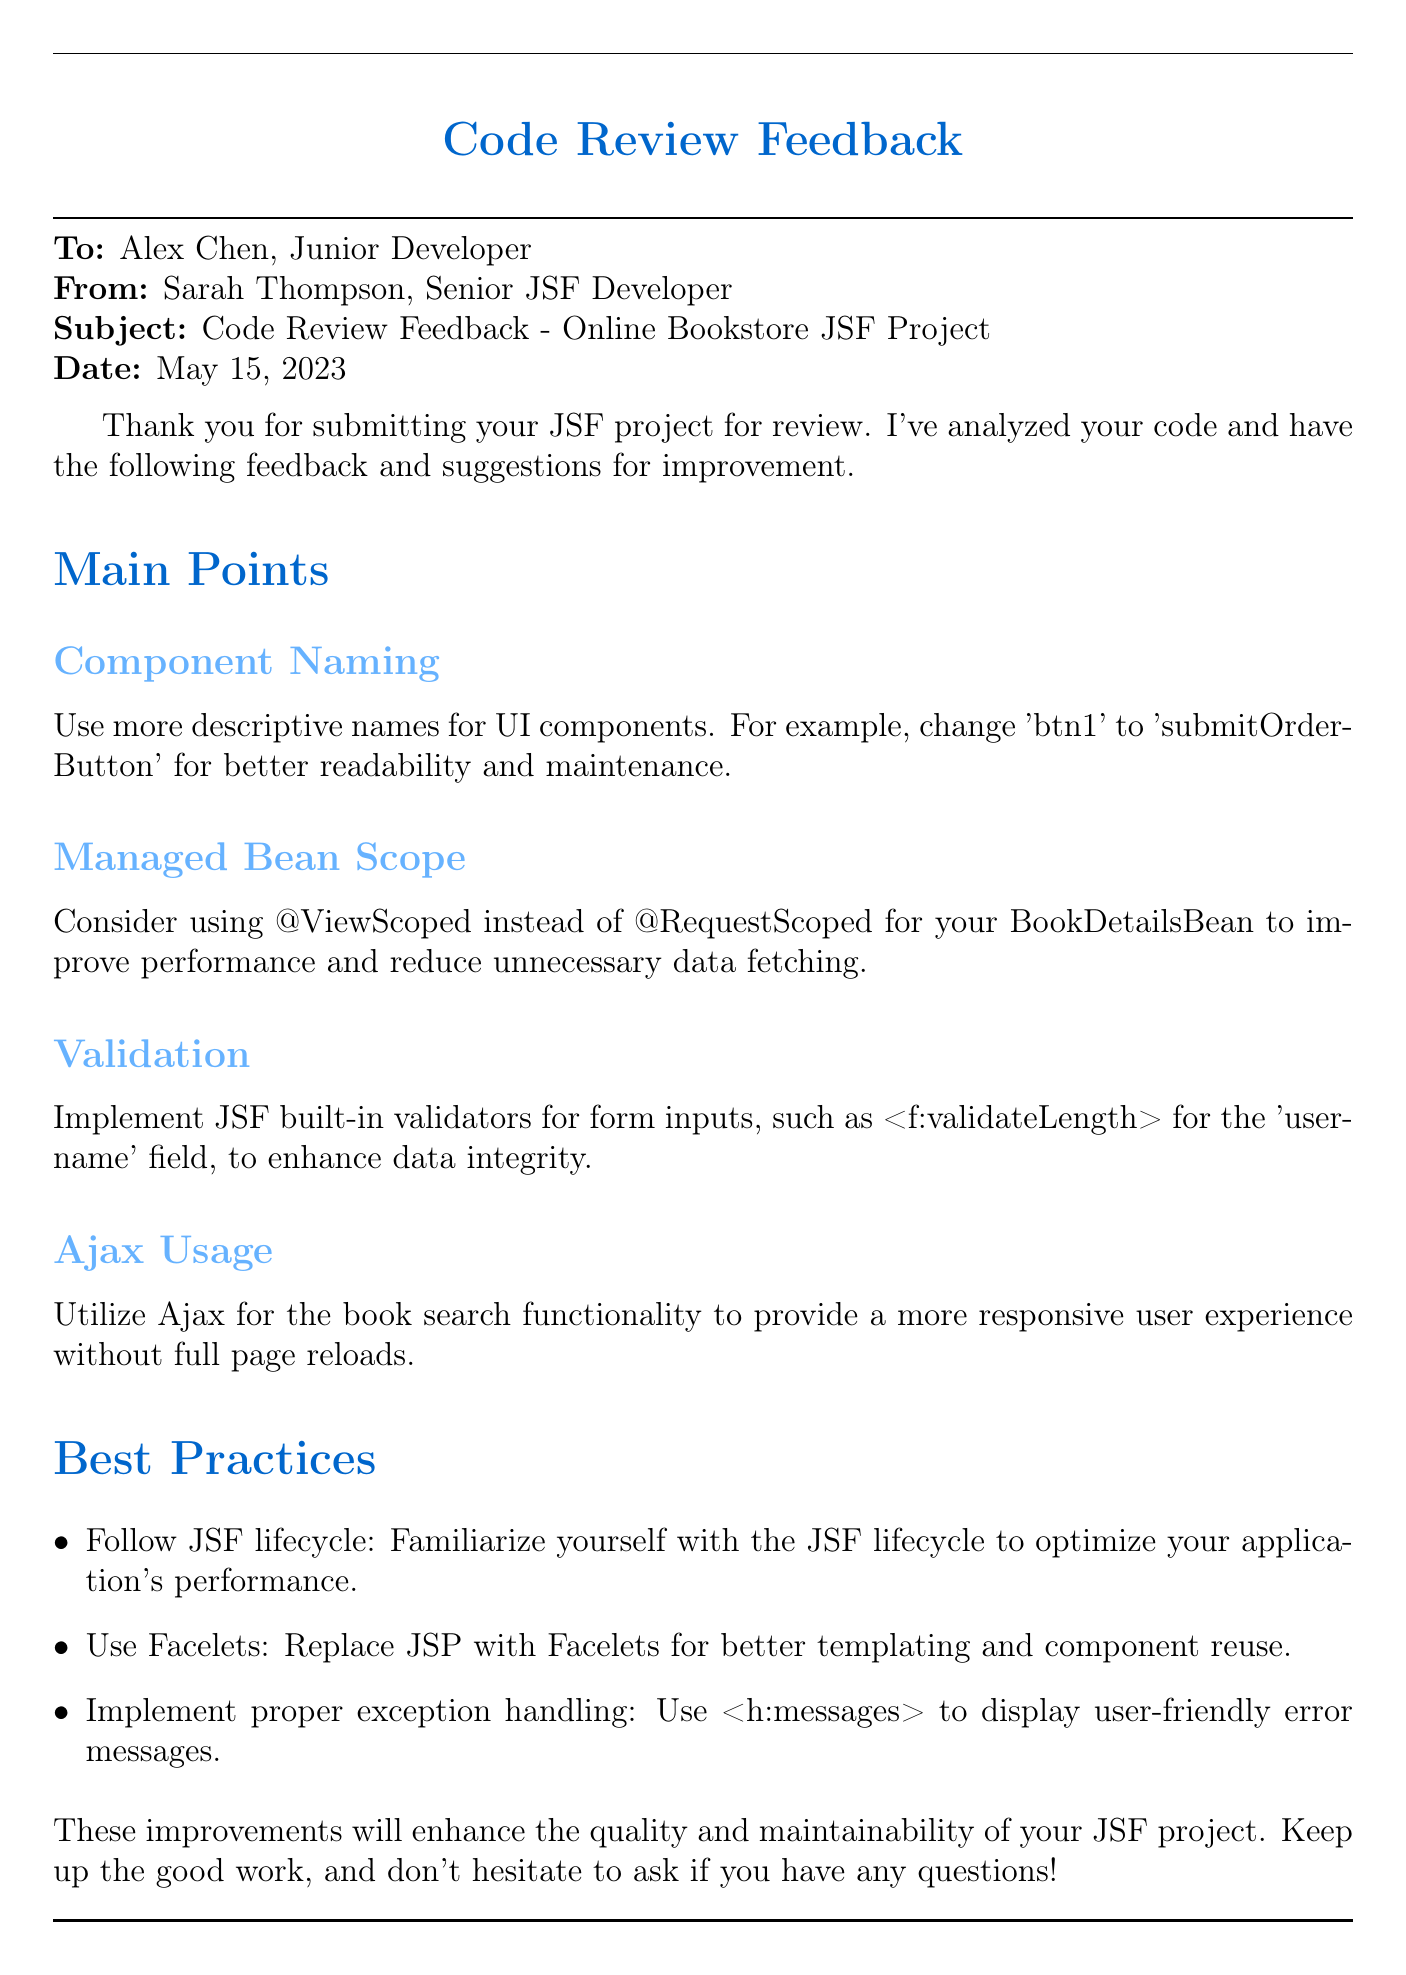What is the name of the junior developer? The junior developer's name is mentioned in the "To" section of the document.
Answer: Alex Chen Who reviewed the JSF project? The reviewer's name is stated in the "From" section of the document.
Answer: Sarah Thompson What is the date of the code review feedback? The date is specified in the "Date" section of the document.
Answer: May 15, 2023 What is the suggested scope for the BookDetailsBean? This suggestion is found in the corresponding sub-section of Main Points in the feedback.
Answer: @ViewScoped What validation is suggested for the 'username' field? The validation type is referenced within the validation advice in Main Points.
Answer: <f:validateLength> Which templating technology is recommended over JSP? The preference is outlined in the best practices section.
Answer: Facelets What should you use to display user-friendly error messages? This guideline is detailed in the best practices section of the document.
Answer: <h:messages> How many main points are listed in the feedback? The count can be inferred by looking at the sections in the document.
Answer: Four What feature is suggested for the book search functionality? The recommendation is made in the Ajax Usage sub-section.
Answer: Ajax 